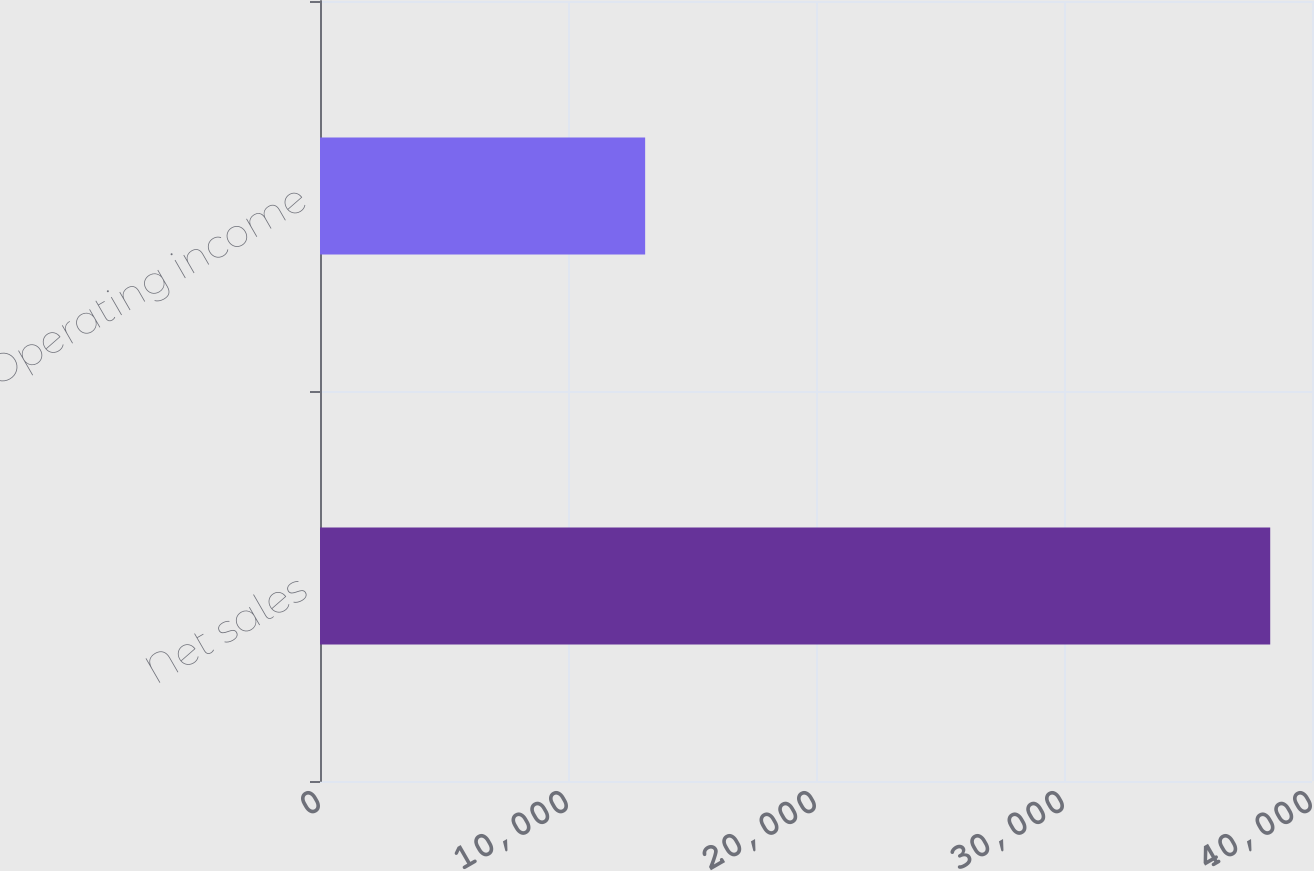Convert chart to OTSL. <chart><loc_0><loc_0><loc_500><loc_500><bar_chart><fcel>Net sales<fcel>Operating income<nl><fcel>38315<fcel>13111<nl></chart> 